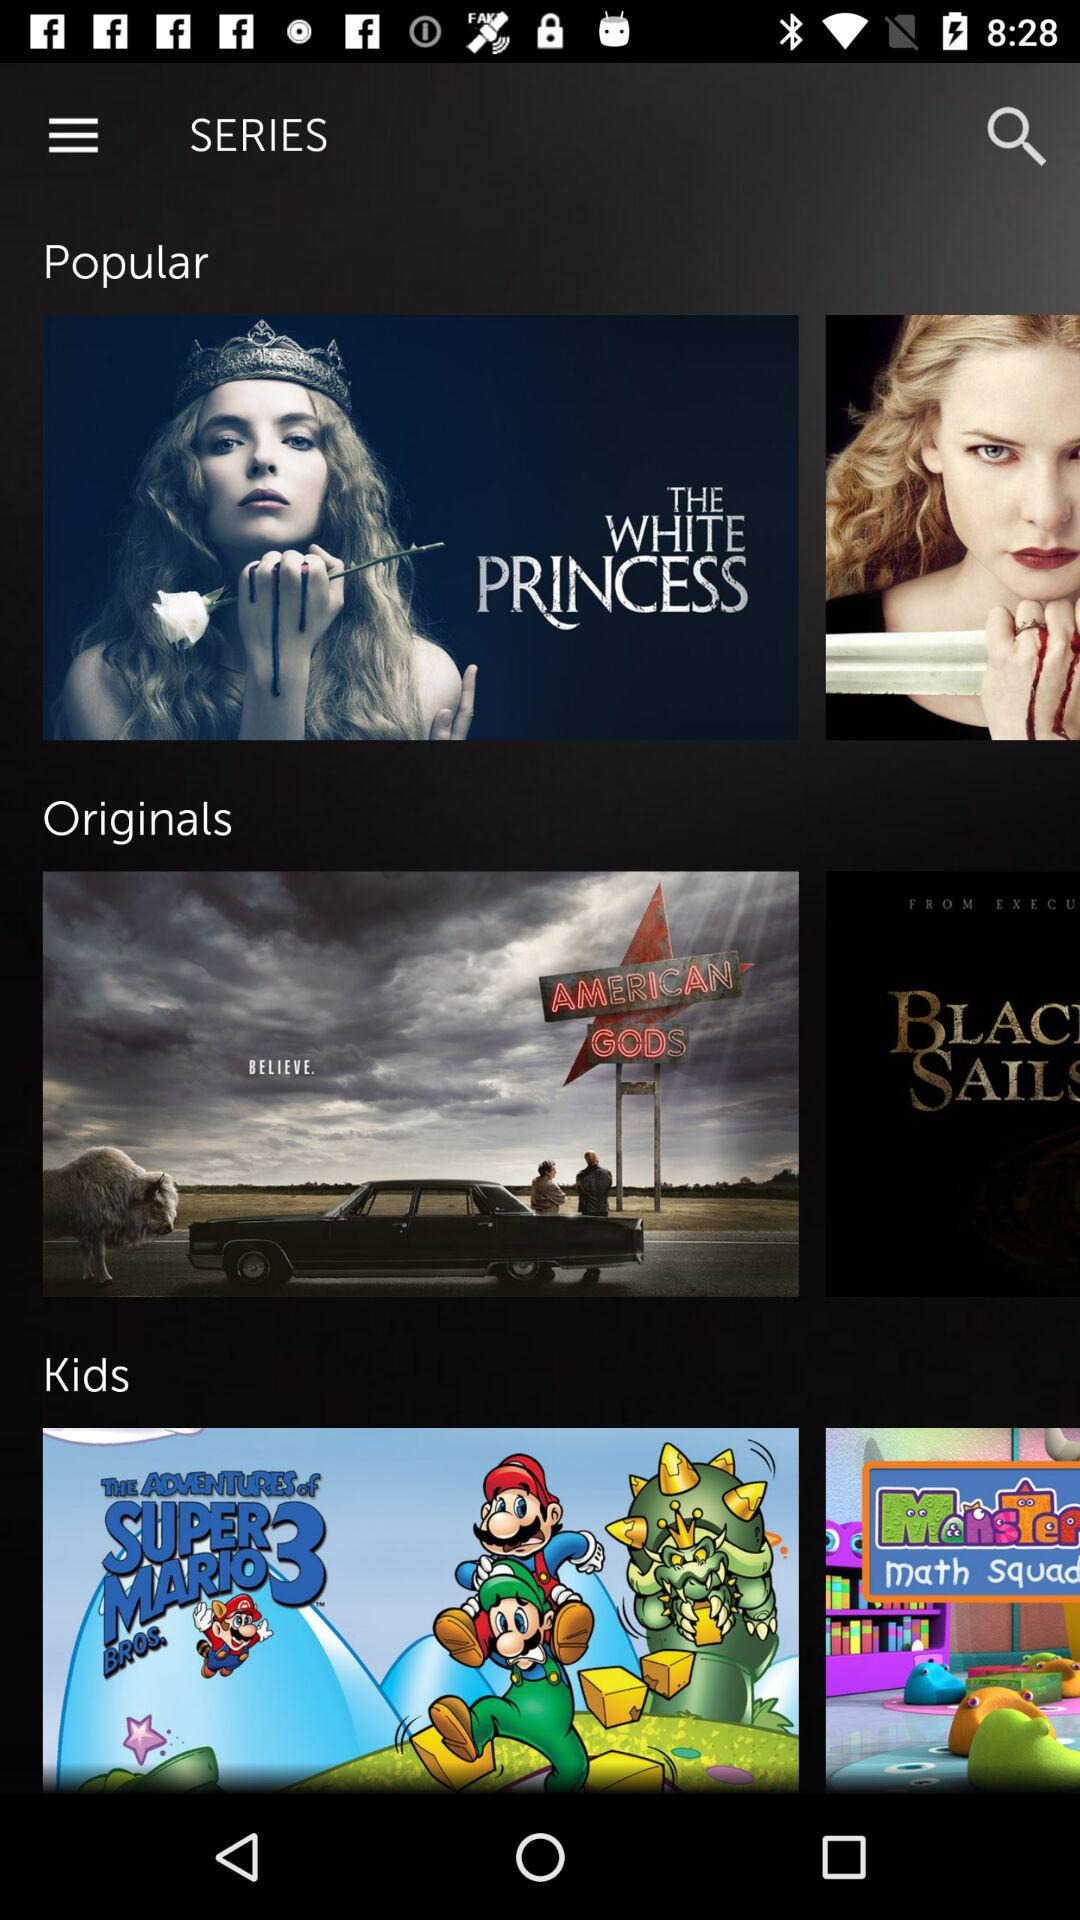What is the name of the popular web series? The name of the popular web series is "THE WHITE PRINCESS". 